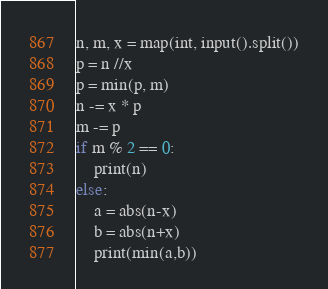<code> <loc_0><loc_0><loc_500><loc_500><_Python_>n, m, x = map(int, input().split())
p = n //x 
p = min(p, m)
n -= x * p
m -= p
if m % 2 == 0:
    print(n)
else:
    a = abs(n-x)
    b = abs(n+x)
    print(min(a,b))
</code> 